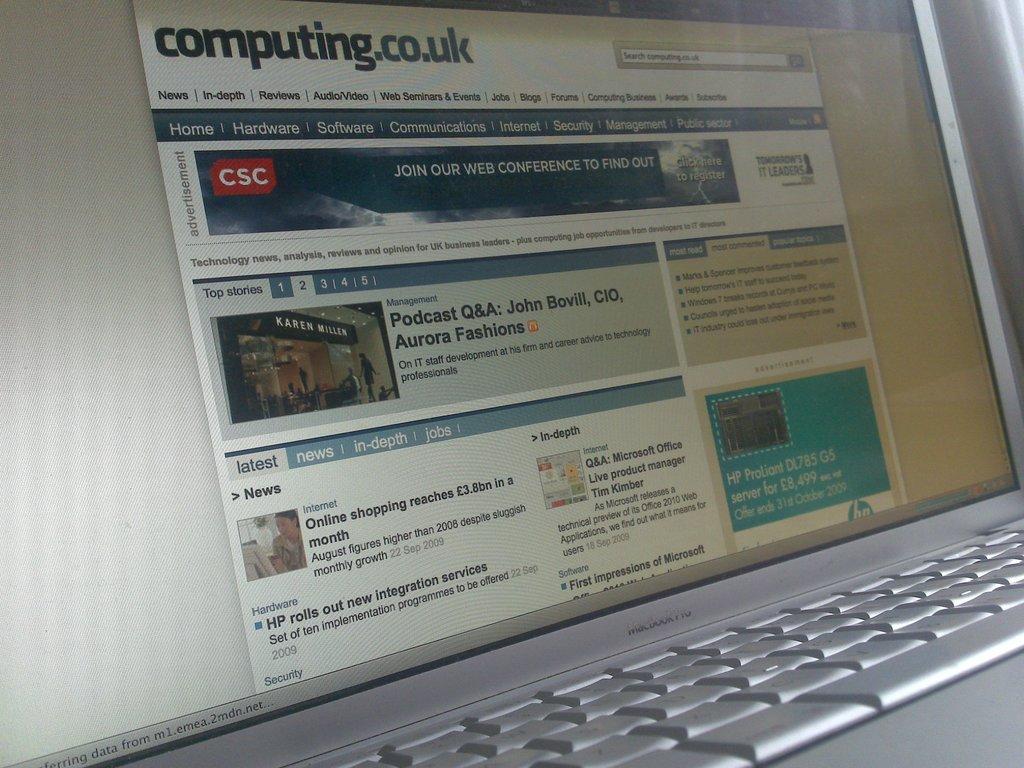Is this a tech informative website?
Provide a short and direct response. Yes. 